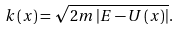<formula> <loc_0><loc_0><loc_500><loc_500>k \left ( x \right ) = \sqrt { 2 m \left | E - U \left ( x \right ) \right | } .</formula> 